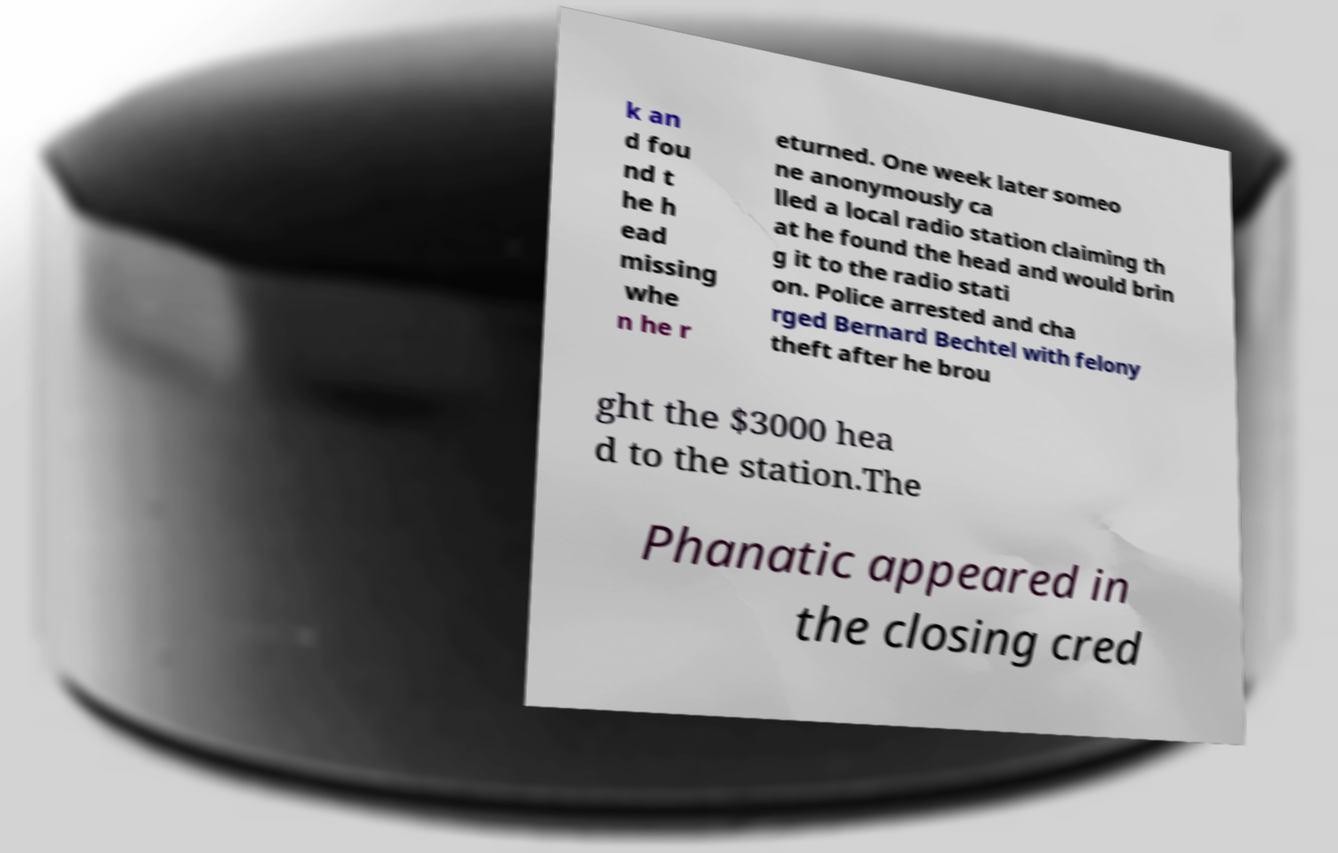I need the written content from this picture converted into text. Can you do that? k an d fou nd t he h ead missing whe n he r eturned. One week later someo ne anonymously ca lled a local radio station claiming th at he found the head and would brin g it to the radio stati on. Police arrested and cha rged Bernard Bechtel with felony theft after he brou ght the $3000 hea d to the station.The Phanatic appeared in the closing cred 